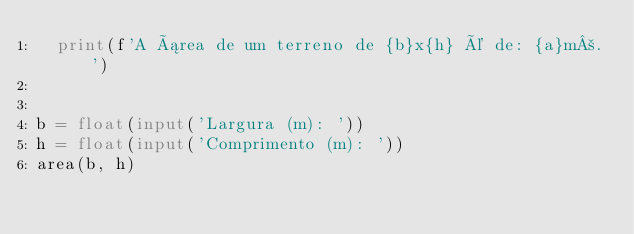Convert code to text. <code><loc_0><loc_0><loc_500><loc_500><_Python_>	print(f'A área de um terreno de {b}x{h} é de: {a}m².')


b = float(input('Largura (m): '))
h = float(input('Comprimento (m): '))
area(b, h)
</code> 